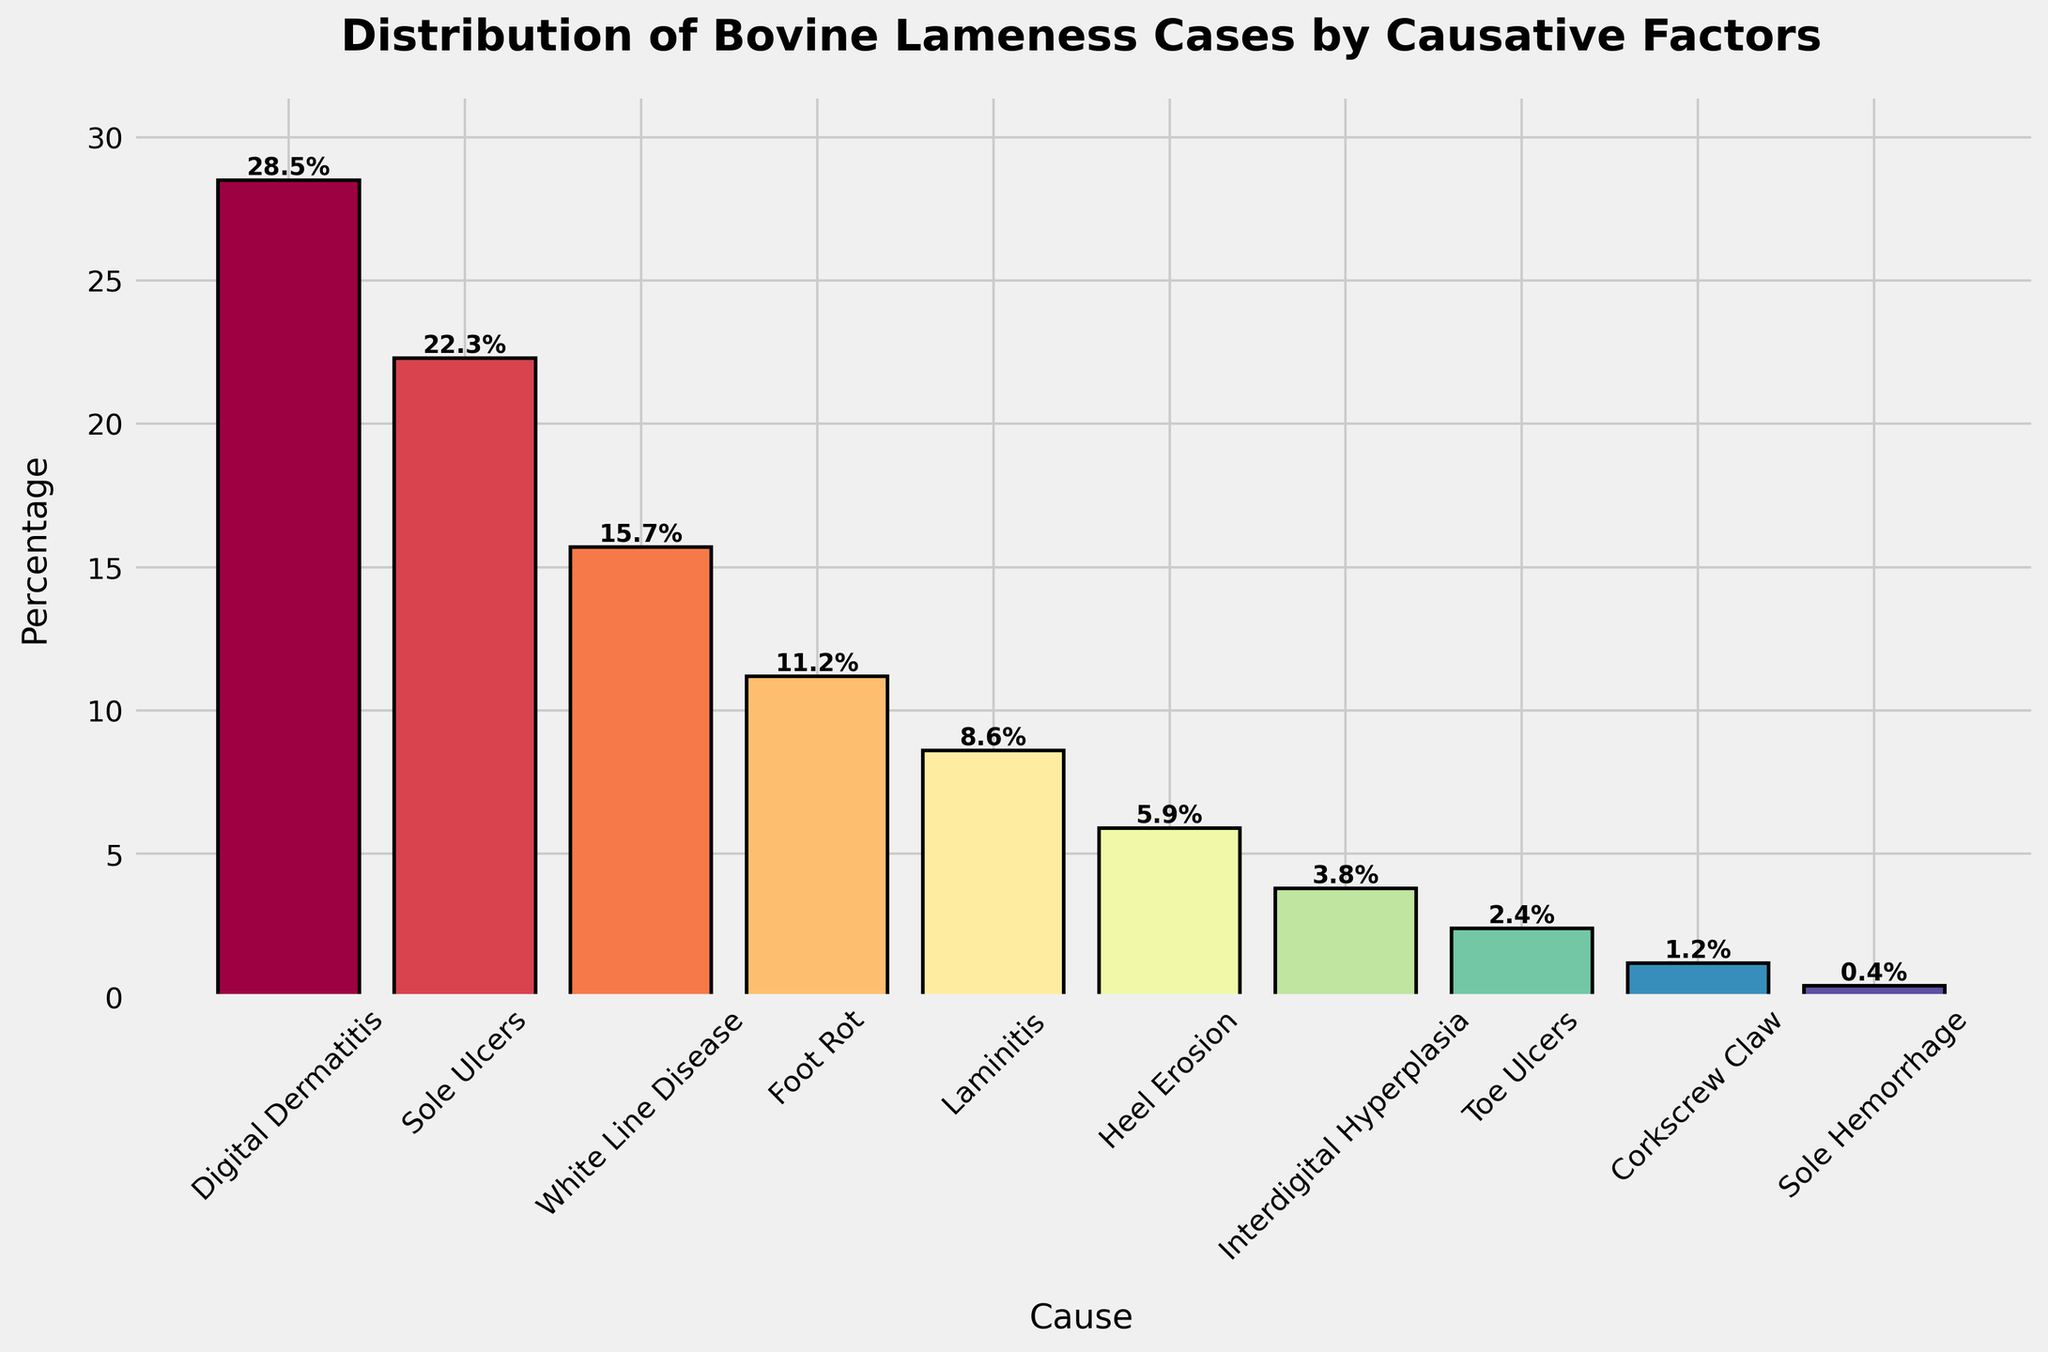Which cause has the highest percentage of bovine lameness cases? The bar representing "Digital Dermatitis" is the tallest, indicating it has the highest percentage.
Answer: Digital Dermatitis Which two causes have the lowest percentage of bovine lameness cases? The bars for "Sole Hemorrhage" and "Corkscrew Claw" are the shortest, indicating they have the lowest percentages.
Answer: Sole Hemorrhage and Corkscrew Claw What is the combined percentage of "Sole Ulcers" and "White Line Disease" lameness cases? The percentages for "Sole Ulcers" and "White Line Disease" are 22.3% and 15.7% respectively. Adding these gives 22.3% + 15.7% = 38%.
Answer: 38% Is the percentage of "Laminitis" cases greater than that of "Foot Rot" cases? The bar for "Laminitis" is lower than the bar for "Foot Rot," indicating that its percentage is less.
Answer: No What is the median percentage value among all the listed causes? To find the median, arrange the percentages in ascending order: 0.4%, 1.2%, 2.4%, 3.8%, 5.9%, 8.6%, 11.2%, 15.7%, 22.3%, 28.5%. The median is the middle value, which is 8.6%.
Answer: 8.6% How much taller is the bar for "Heel Erosion" compared to the bar for "Interdigital Hyperplasia"? The percentage for "Heel Erosion" is 5.9%, and for "Interdigital Hyperplasia" it is 3.8%. The difference is 5.9% - 3.8% = 2.1%.
Answer: 2.1% Which cause of bovine lameness has a percentage closest to 10%? The bar representing "Foot Rot" is closest to the 10% mark, with a percentage of 11.2%.
Answer: Foot Rot What is the total percentage of all the causes combined? Adding up all the percentages: 28.5% + 22.3% + 15.7% + 11.2% + 8.6% + 5.9% + 3.8% + 2.4% + 1.2% + 0.4% = 100%.
Answer: 100% Which causes are represented with bars above 20%? The bars for "Digital Dermatitis" and "Sole Ulcers" are both above the 20% mark.
Answer: Digital Dermatitis and Sole Ulcers 